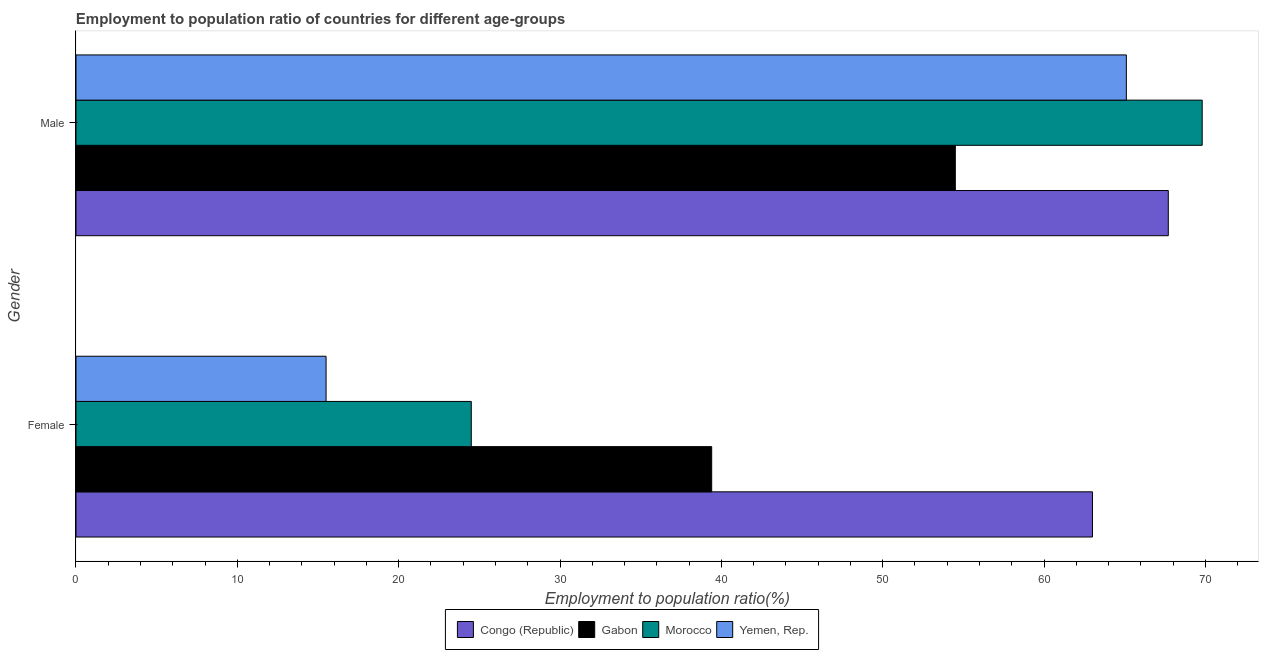How many groups of bars are there?
Your response must be concise. 2. Are the number of bars on each tick of the Y-axis equal?
Offer a terse response. Yes. How many bars are there on the 2nd tick from the top?
Provide a short and direct response. 4. How many bars are there on the 1st tick from the bottom?
Your response must be concise. 4. What is the label of the 1st group of bars from the top?
Provide a short and direct response. Male. What is the employment to population ratio(female) in Congo (Republic)?
Your answer should be compact. 63. Across all countries, what is the maximum employment to population ratio(male)?
Your answer should be very brief. 69.8. Across all countries, what is the minimum employment to population ratio(male)?
Your response must be concise. 54.5. In which country was the employment to population ratio(male) maximum?
Make the answer very short. Morocco. In which country was the employment to population ratio(male) minimum?
Provide a succinct answer. Gabon. What is the total employment to population ratio(male) in the graph?
Ensure brevity in your answer.  257.1. What is the difference between the employment to population ratio(male) in Morocco and that in Yemen, Rep.?
Your response must be concise. 4.7. What is the difference between the employment to population ratio(female) in Congo (Republic) and the employment to population ratio(male) in Morocco?
Offer a terse response. -6.8. What is the average employment to population ratio(female) per country?
Keep it short and to the point. 35.6. What is the difference between the employment to population ratio(male) and employment to population ratio(female) in Morocco?
Provide a succinct answer. 45.3. What is the ratio of the employment to population ratio(male) in Morocco to that in Congo (Republic)?
Offer a very short reply. 1.03. In how many countries, is the employment to population ratio(male) greater than the average employment to population ratio(male) taken over all countries?
Offer a very short reply. 3. What does the 1st bar from the top in Male represents?
Your answer should be very brief. Yemen, Rep. What does the 1st bar from the bottom in Male represents?
Provide a short and direct response. Congo (Republic). How many countries are there in the graph?
Provide a short and direct response. 4. What is the difference between two consecutive major ticks on the X-axis?
Keep it short and to the point. 10. Does the graph contain grids?
Provide a succinct answer. No. Where does the legend appear in the graph?
Offer a terse response. Bottom center. What is the title of the graph?
Make the answer very short. Employment to population ratio of countries for different age-groups. Does "Singapore" appear as one of the legend labels in the graph?
Ensure brevity in your answer.  No. What is the label or title of the Y-axis?
Your answer should be very brief. Gender. What is the Employment to population ratio(%) in Congo (Republic) in Female?
Your answer should be compact. 63. What is the Employment to population ratio(%) in Gabon in Female?
Your answer should be compact. 39.4. What is the Employment to population ratio(%) of Yemen, Rep. in Female?
Ensure brevity in your answer.  15.5. What is the Employment to population ratio(%) of Congo (Republic) in Male?
Provide a succinct answer. 67.7. What is the Employment to population ratio(%) of Gabon in Male?
Give a very brief answer. 54.5. What is the Employment to population ratio(%) in Morocco in Male?
Give a very brief answer. 69.8. What is the Employment to population ratio(%) in Yemen, Rep. in Male?
Ensure brevity in your answer.  65.1. Across all Gender, what is the maximum Employment to population ratio(%) of Congo (Republic)?
Provide a succinct answer. 67.7. Across all Gender, what is the maximum Employment to population ratio(%) in Gabon?
Ensure brevity in your answer.  54.5. Across all Gender, what is the maximum Employment to population ratio(%) of Morocco?
Your answer should be very brief. 69.8. Across all Gender, what is the maximum Employment to population ratio(%) of Yemen, Rep.?
Make the answer very short. 65.1. Across all Gender, what is the minimum Employment to population ratio(%) of Gabon?
Your answer should be compact. 39.4. What is the total Employment to population ratio(%) of Congo (Republic) in the graph?
Make the answer very short. 130.7. What is the total Employment to population ratio(%) of Gabon in the graph?
Your response must be concise. 93.9. What is the total Employment to population ratio(%) of Morocco in the graph?
Keep it short and to the point. 94.3. What is the total Employment to population ratio(%) of Yemen, Rep. in the graph?
Ensure brevity in your answer.  80.6. What is the difference between the Employment to population ratio(%) of Congo (Republic) in Female and that in Male?
Your answer should be compact. -4.7. What is the difference between the Employment to population ratio(%) in Gabon in Female and that in Male?
Your response must be concise. -15.1. What is the difference between the Employment to population ratio(%) in Morocco in Female and that in Male?
Provide a short and direct response. -45.3. What is the difference between the Employment to population ratio(%) in Yemen, Rep. in Female and that in Male?
Offer a terse response. -49.6. What is the difference between the Employment to population ratio(%) in Gabon in Female and the Employment to population ratio(%) in Morocco in Male?
Your answer should be very brief. -30.4. What is the difference between the Employment to population ratio(%) of Gabon in Female and the Employment to population ratio(%) of Yemen, Rep. in Male?
Provide a short and direct response. -25.7. What is the difference between the Employment to population ratio(%) in Morocco in Female and the Employment to population ratio(%) in Yemen, Rep. in Male?
Your response must be concise. -40.6. What is the average Employment to population ratio(%) of Congo (Republic) per Gender?
Ensure brevity in your answer.  65.35. What is the average Employment to population ratio(%) in Gabon per Gender?
Your answer should be very brief. 46.95. What is the average Employment to population ratio(%) of Morocco per Gender?
Keep it short and to the point. 47.15. What is the average Employment to population ratio(%) in Yemen, Rep. per Gender?
Your answer should be compact. 40.3. What is the difference between the Employment to population ratio(%) of Congo (Republic) and Employment to population ratio(%) of Gabon in Female?
Ensure brevity in your answer.  23.6. What is the difference between the Employment to population ratio(%) in Congo (Republic) and Employment to population ratio(%) in Morocco in Female?
Provide a short and direct response. 38.5. What is the difference between the Employment to population ratio(%) of Congo (Republic) and Employment to population ratio(%) of Yemen, Rep. in Female?
Provide a short and direct response. 47.5. What is the difference between the Employment to population ratio(%) of Gabon and Employment to population ratio(%) of Morocco in Female?
Your answer should be very brief. 14.9. What is the difference between the Employment to population ratio(%) in Gabon and Employment to population ratio(%) in Yemen, Rep. in Female?
Provide a short and direct response. 23.9. What is the difference between the Employment to population ratio(%) of Morocco and Employment to population ratio(%) of Yemen, Rep. in Female?
Make the answer very short. 9. What is the difference between the Employment to population ratio(%) in Congo (Republic) and Employment to population ratio(%) in Gabon in Male?
Ensure brevity in your answer.  13.2. What is the difference between the Employment to population ratio(%) in Gabon and Employment to population ratio(%) in Morocco in Male?
Ensure brevity in your answer.  -15.3. What is the difference between the Employment to population ratio(%) in Morocco and Employment to population ratio(%) in Yemen, Rep. in Male?
Make the answer very short. 4.7. What is the ratio of the Employment to population ratio(%) in Congo (Republic) in Female to that in Male?
Ensure brevity in your answer.  0.93. What is the ratio of the Employment to population ratio(%) in Gabon in Female to that in Male?
Offer a very short reply. 0.72. What is the ratio of the Employment to population ratio(%) in Morocco in Female to that in Male?
Keep it short and to the point. 0.35. What is the ratio of the Employment to population ratio(%) in Yemen, Rep. in Female to that in Male?
Your answer should be very brief. 0.24. What is the difference between the highest and the second highest Employment to population ratio(%) of Gabon?
Give a very brief answer. 15.1. What is the difference between the highest and the second highest Employment to population ratio(%) of Morocco?
Your answer should be compact. 45.3. What is the difference between the highest and the second highest Employment to population ratio(%) in Yemen, Rep.?
Provide a short and direct response. 49.6. What is the difference between the highest and the lowest Employment to population ratio(%) in Congo (Republic)?
Make the answer very short. 4.7. What is the difference between the highest and the lowest Employment to population ratio(%) in Morocco?
Ensure brevity in your answer.  45.3. What is the difference between the highest and the lowest Employment to population ratio(%) of Yemen, Rep.?
Provide a short and direct response. 49.6. 